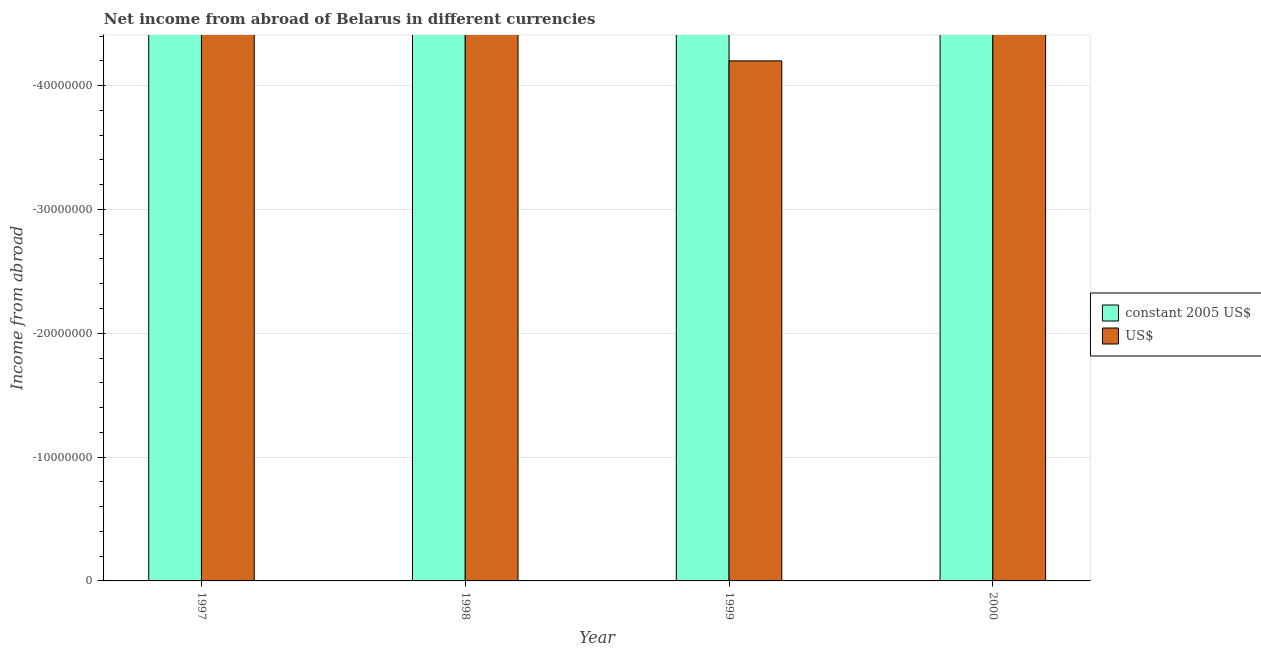How many different coloured bars are there?
Make the answer very short. 0. Are the number of bars on each tick of the X-axis equal?
Keep it short and to the point. Yes. What is the label of the 3rd group of bars from the left?
Provide a succinct answer. 1999. In how many cases, is the number of bars for a given year not equal to the number of legend labels?
Your response must be concise. 4. What is the income from abroad in us$ in 1999?
Ensure brevity in your answer.  0. Across all years, what is the minimum income from abroad in us$?
Your response must be concise. 0. What is the difference between the income from abroad in us$ in 1997 and the income from abroad in constant 2005 us$ in 2000?
Provide a succinct answer. 0. In how many years, is the income from abroad in us$ greater than -44000000 units?
Keep it short and to the point. 1. How many bars are there?
Your answer should be very brief. 0. How many years are there in the graph?
Give a very brief answer. 4. What is the difference between two consecutive major ticks on the Y-axis?
Give a very brief answer. 1.00e+07. Are the values on the major ticks of Y-axis written in scientific E-notation?
Ensure brevity in your answer.  No. Does the graph contain grids?
Keep it short and to the point. Yes. How many legend labels are there?
Keep it short and to the point. 2. How are the legend labels stacked?
Give a very brief answer. Vertical. What is the title of the graph?
Ensure brevity in your answer.  Net income from abroad of Belarus in different currencies. Does "Resident workers" appear as one of the legend labels in the graph?
Your answer should be very brief. No. What is the label or title of the X-axis?
Provide a short and direct response. Year. What is the label or title of the Y-axis?
Provide a short and direct response. Income from abroad. What is the Income from abroad in constant 2005 US$ in 1997?
Provide a short and direct response. 0. What is the Income from abroad in US$ in 1998?
Ensure brevity in your answer.  0. What is the Income from abroad in US$ in 1999?
Your answer should be compact. 0. What is the total Income from abroad of constant 2005 US$ in the graph?
Keep it short and to the point. 0. 